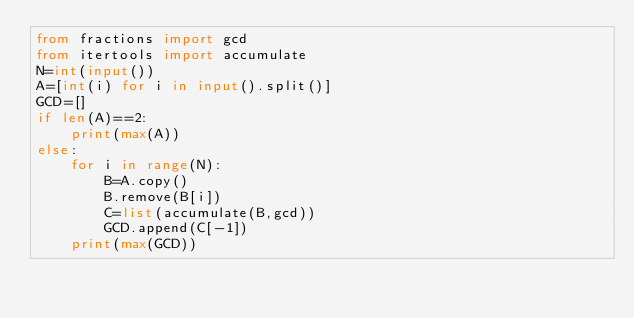Convert code to text. <code><loc_0><loc_0><loc_500><loc_500><_Python_>from fractions import gcd
from itertools import accumulate
N=int(input())
A=[int(i) for i in input().split()]
GCD=[]
if len(A)==2:
    print(max(A))
else:
    for i in range(N):
        B=A.copy()
        B.remove(B[i])
        C=list(accumulate(B,gcd))
        GCD.append(C[-1])
    print(max(GCD))</code> 